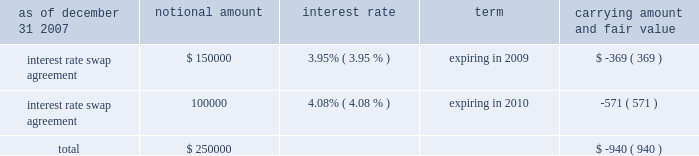American tower corporation and subsidiaries notes to consolidated financial statements 2014 ( continued ) market and lease the unused tower space on the broadcast towers ( the economic rights ) .
Tv azteca retains title to these towers and is responsible for their operation and maintenance .
The company is entitled to 100% ( 100 % ) of the revenues generated from leases with tenants on the unused space and is responsible for any incremental operating expenses associated with those tenants .
The term of the economic rights agreement is seventy years ; however , tv azteca has the right to purchase , at fair market value , the economic rights from the company at any time during the last fifty years of the agreement .
Should tv azteca elect to purchase the economic rights ( in whole or in part ) , it would also be obligated to repay a proportional amount of the loan discussed above at the time of such election .
The company 2019s obligation to pay tv azteca $ 1.5 million annually would also be reduced proportionally .
The company has accounted for the annual payment of $ 1.5 million as a capital lease ( initially recording an asset and a corresponding liability of approximately $ 18.6 million ) .
The capital lease asset and the discount on the note , which aggregate approximately $ 30.2 million , represent the cost to acquire the economic rights and are being amortized over the seventy-year life of the economic rights agreement .
On a quarterly basis , the company assesses the recoverability of its note receivable from tv azteca .
As of december 31 , 2007 and 2006 , the company has assessed the recoverability of the note receivable from tv azteca and concluded that no adjustment to its carrying value is required .
A former executive officer and former director of the company served as a director of tv azteca from december 1999 to february 2006 .
As of december 31 , 2007 and 2006 , the company also had other long-term notes receivable outstanding of approximately $ 4.3 million and $ 11.0 million , respectively .
Derivative financial instruments the company enters into interest rate protection agreements to manage exposure on the variable rate debt under its credit facilities and to manage variability in cash flows relating to forecasted interest payments .
Under these agreements , the company is exposed to credit risk to the extent that a counterparty fails to meet the terms of a contract .
Such exposure was limited to the current value of the contract at the time the counterparty fails to perform .
The company believes its contracts as of december 31 , 2007 and 2006 are with credit worthy institutions .
As of december 31 , 2007 and 2006 , the carrying amounts of the company 2019s derivative financial instruments , along with the estimated fair values of the related assets reflected in notes receivable and other long-term assets and ( liabilities ) reflected in other long-term liabilities in the accompanying consolidated balance sheet , are as follows ( in thousands except percentages ) : as of december 31 , 2007 notional amount interest rate term carrying amount and fair value .

How is cash flow affected by the change in the balance of other long-term notes receivable during 2007? 
Computations: (4.3 - 11.0)
Answer: -6.7. 